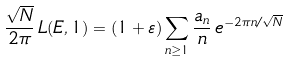<formula> <loc_0><loc_0><loc_500><loc_500>\frac { \sqrt { N } } { 2 \pi } \, L ( E , 1 ) = ( 1 + \varepsilon ) \sum _ { n \geq 1 } \frac { a _ { n } } n \, e ^ { - 2 \pi n / \sqrt { N } }</formula> 